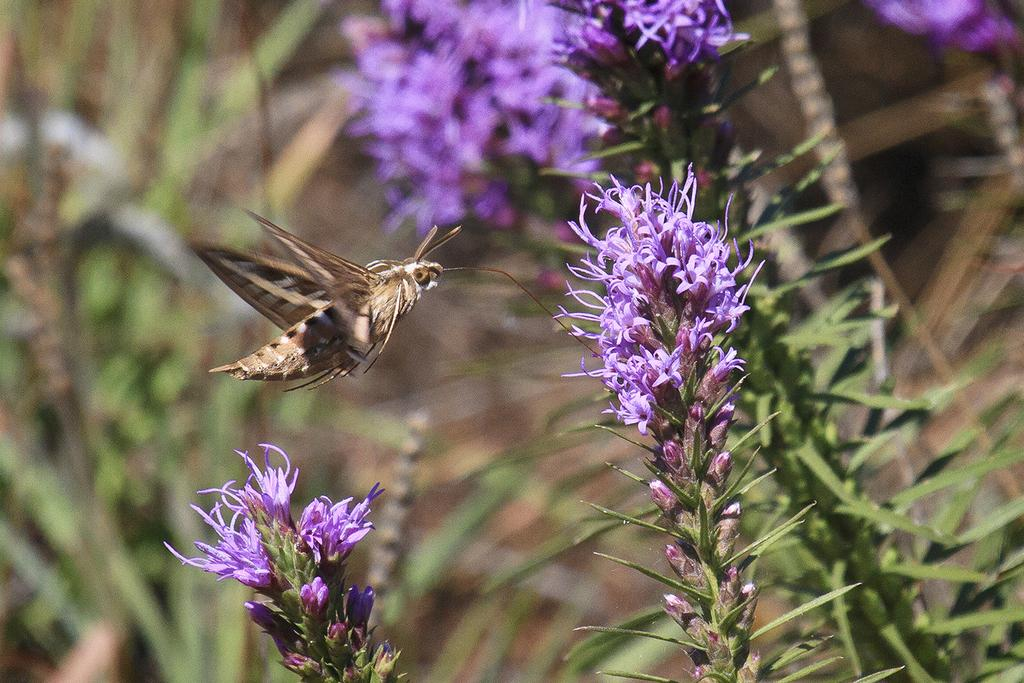What type of plants are in the foreground of the image? There are flower plants in the foreground area of the image. What else can be seen in the foreground area of the image? There is an insect in the foreground area of the image. What type of mask is the insect wearing in the image? A: There is no mask present on the insect in the image. How many spots can be seen on the arm of the insect in the image? There is no arm or spots visible on the insect in the image. 